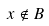Convert formula to latex. <formula><loc_0><loc_0><loc_500><loc_500>x \notin B</formula> 